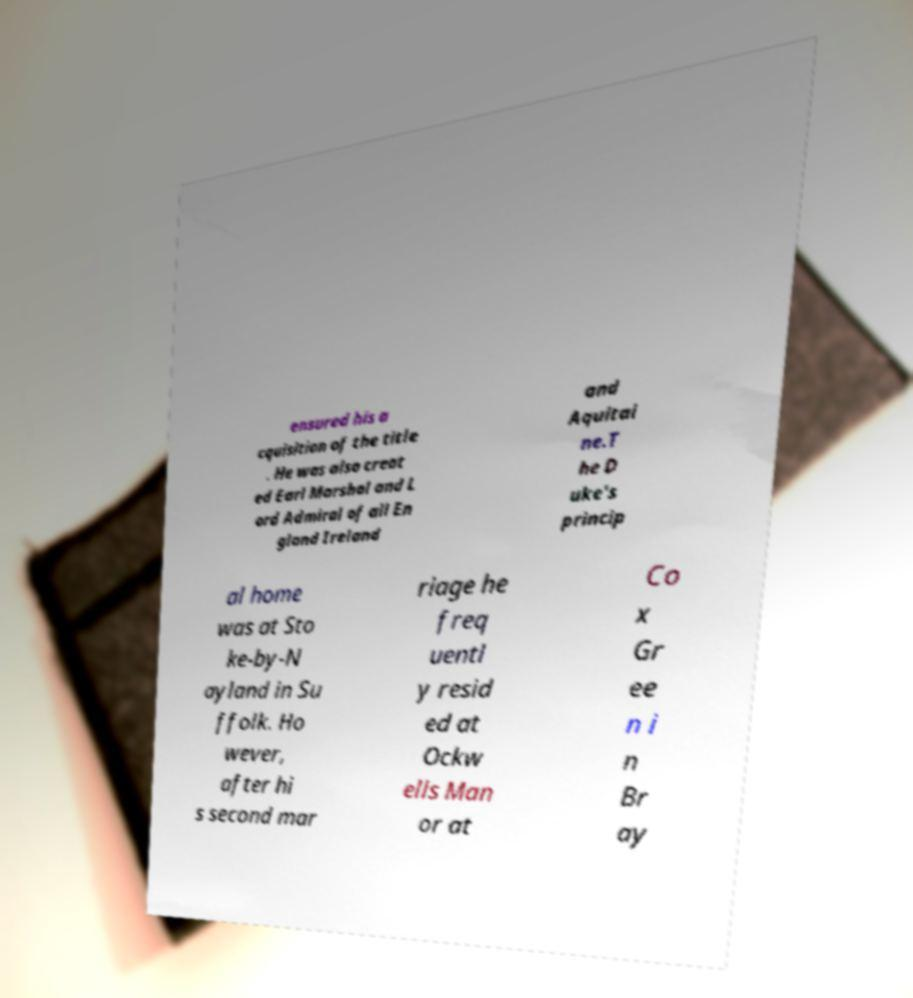Could you assist in decoding the text presented in this image and type it out clearly? ensured his a cquisition of the title . He was also creat ed Earl Marshal and L ord Admiral of all En gland Ireland and Aquitai ne.T he D uke's princip al home was at Sto ke-by-N ayland in Su ffolk. Ho wever, after hi s second mar riage he freq uentl y resid ed at Ockw ells Man or at Co x Gr ee n i n Br ay 